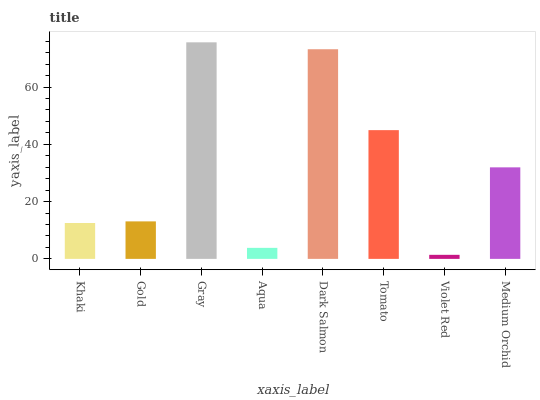Is Gold the minimum?
Answer yes or no. No. Is Gold the maximum?
Answer yes or no. No. Is Gold greater than Khaki?
Answer yes or no. Yes. Is Khaki less than Gold?
Answer yes or no. Yes. Is Khaki greater than Gold?
Answer yes or no. No. Is Gold less than Khaki?
Answer yes or no. No. Is Medium Orchid the high median?
Answer yes or no. Yes. Is Gold the low median?
Answer yes or no. Yes. Is Dark Salmon the high median?
Answer yes or no. No. Is Violet Red the low median?
Answer yes or no. No. 